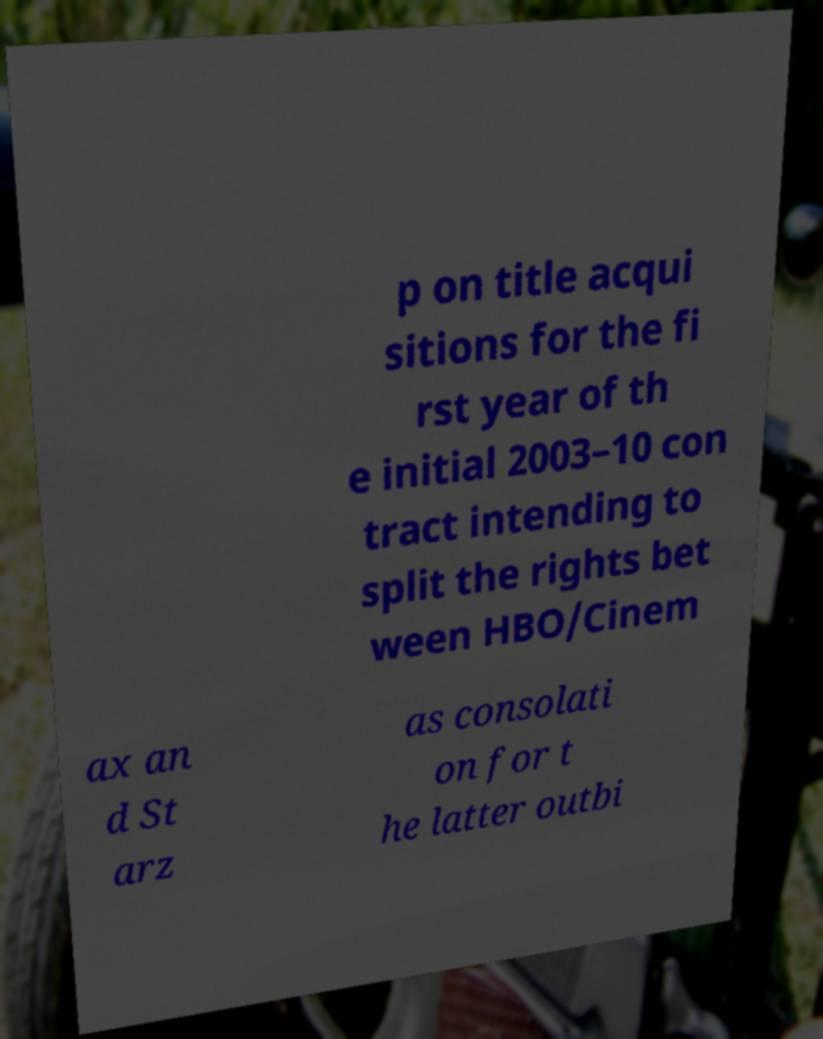Please read and relay the text visible in this image. What does it say? p on title acqui sitions for the fi rst year of th e initial 2003–10 con tract intending to split the rights bet ween HBO/Cinem ax an d St arz as consolati on for t he latter outbi 